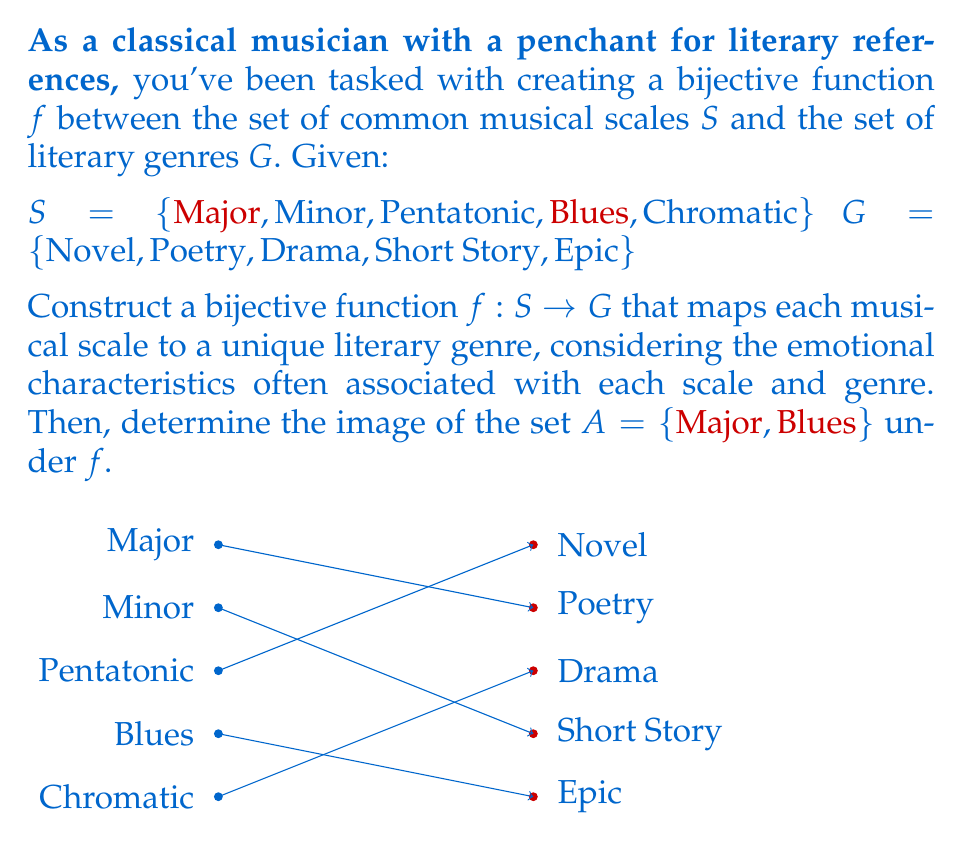Solve this math problem. To solve this problem, we need to construct a bijective function and then find the image of a subset. Let's approach this step-by-step:

1) First, let's construct a bijective function $f: S \rightarrow G$. A bijective function is both injective (one-to-one) and surjective (onto). We need to map each element in $S$ to a unique element in $G$. One possible mapping, considering emotional characteristics, could be:

   $f(\text{Major}) = \text{Novel}$ (both often associated with a wide range of emotions)
   $f(\text{Minor}) = \text{Drama}$ (both often associated with depth and intensity)
   $f(\text{Pentatonic}) = \text{Poetry}$ (both often associated with simplicity and emotion)
   $f(\text{Blues}) = \text{Short Story}$ (both often concise and emotionally impactful)
   $f(\text{Chromatic}) = \text{Epic}$ (both often complex and all-encompassing)

2) This function is bijective because:
   - It's injective: each element in $S$ maps to a unique element in $G$
   - It's surjective: every element in $G$ is mapped to by an element in $S$
   - The sets $S$ and $G$ have the same number of elements (5)

3) Now, we need to find the image of the set $A = \{\text{Major}, \text{Blues}\}$ under $f$. 
   The image of a set under a function is the set of all outputs for the given inputs.

4) We can find this by applying $f$ to each element in $A$:
   $f(\text{Major}) = \text{Novel}$
   $f(\text{Blues}) = \text{Short Story}$

5) Therefore, the image of $A$ under $f$ is $\{\text{Novel}, \text{Short Story}\}$
Answer: $f(A) = \{\text{Novel}, \text{Short Story}\}$ 